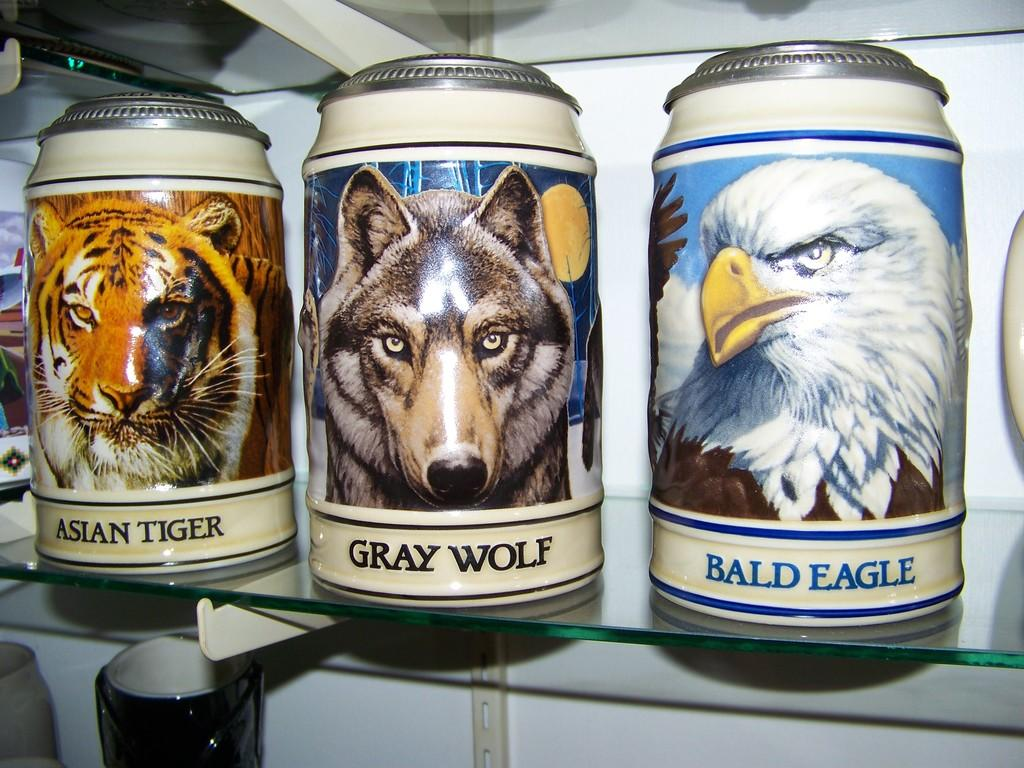What objects are on the glass shelf in the image? There are jars on a glass shelf in the image. What can be seen on the jars? The jars have pictures of animals on them. What type of operation is being performed on the earth in the image? There is no operation or reference to the earth in the image; it only features jars with pictures of animals on them. 